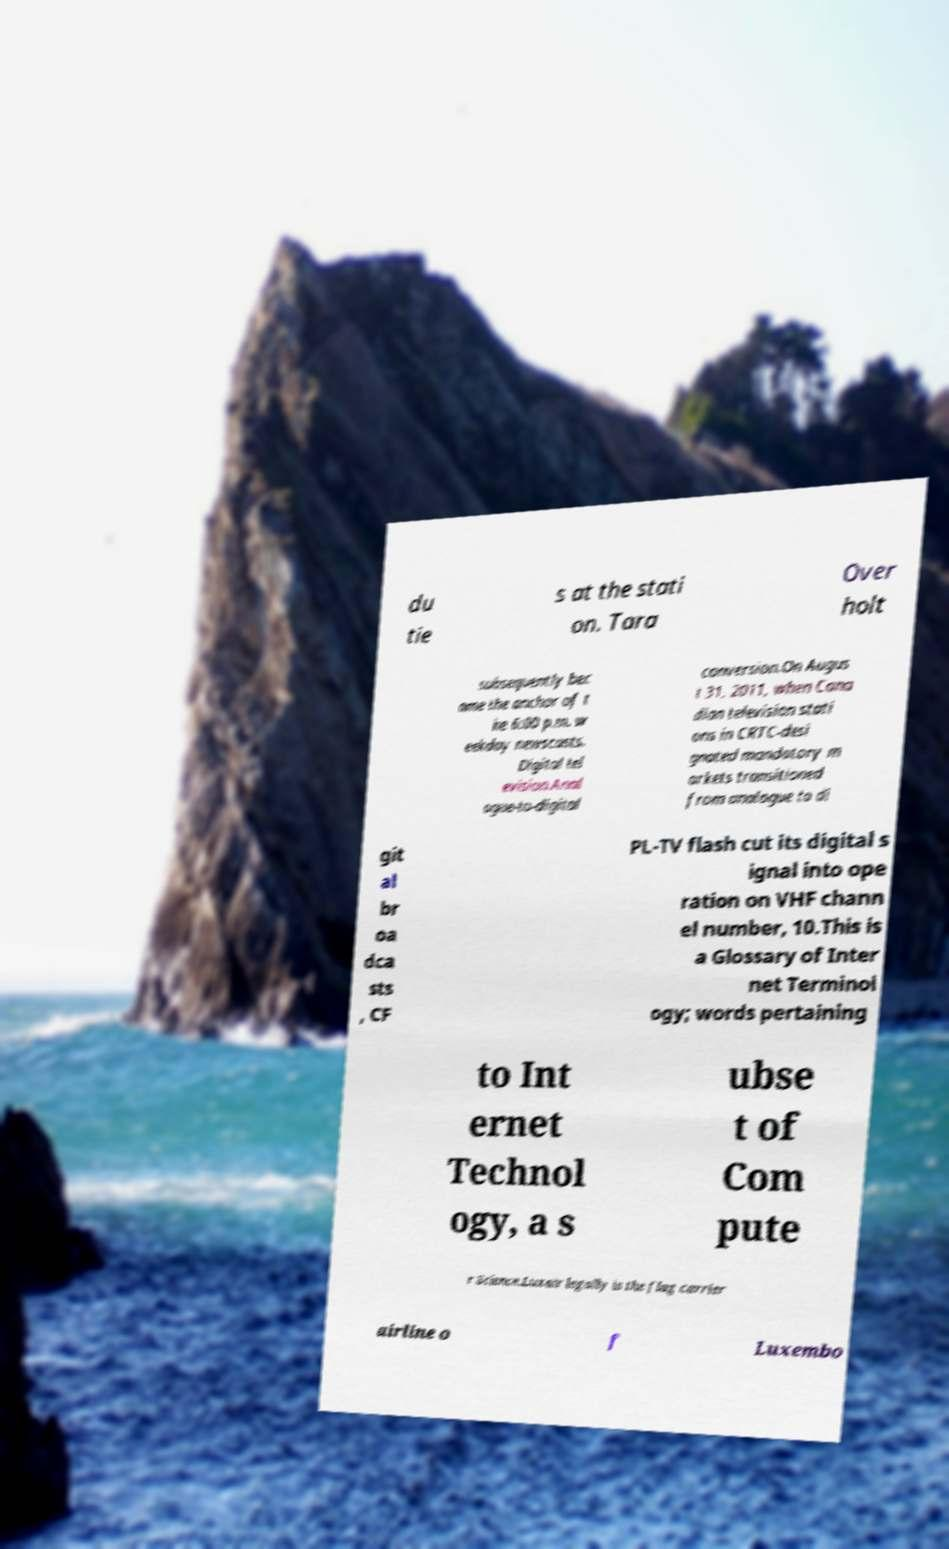Please read and relay the text visible in this image. What does it say? du tie s at the stati on. Tara Over holt subsequently bec ame the anchor of t he 6:00 p.m. w eekday newscasts. Digital tel evision.Anal ogue-to-digital conversion.On Augus t 31, 2011, when Cana dian television stati ons in CRTC-desi gnated mandatory m arkets transitioned from analogue to di git al br oa dca sts , CF PL-TV flash cut its digital s ignal into ope ration on VHF chann el number, 10.This is a Glossary of Inter net Terminol ogy; words pertaining to Int ernet Technol ogy, a s ubse t of Com pute r Science.Luxair legally is the flag carrier airline o f Luxembo 